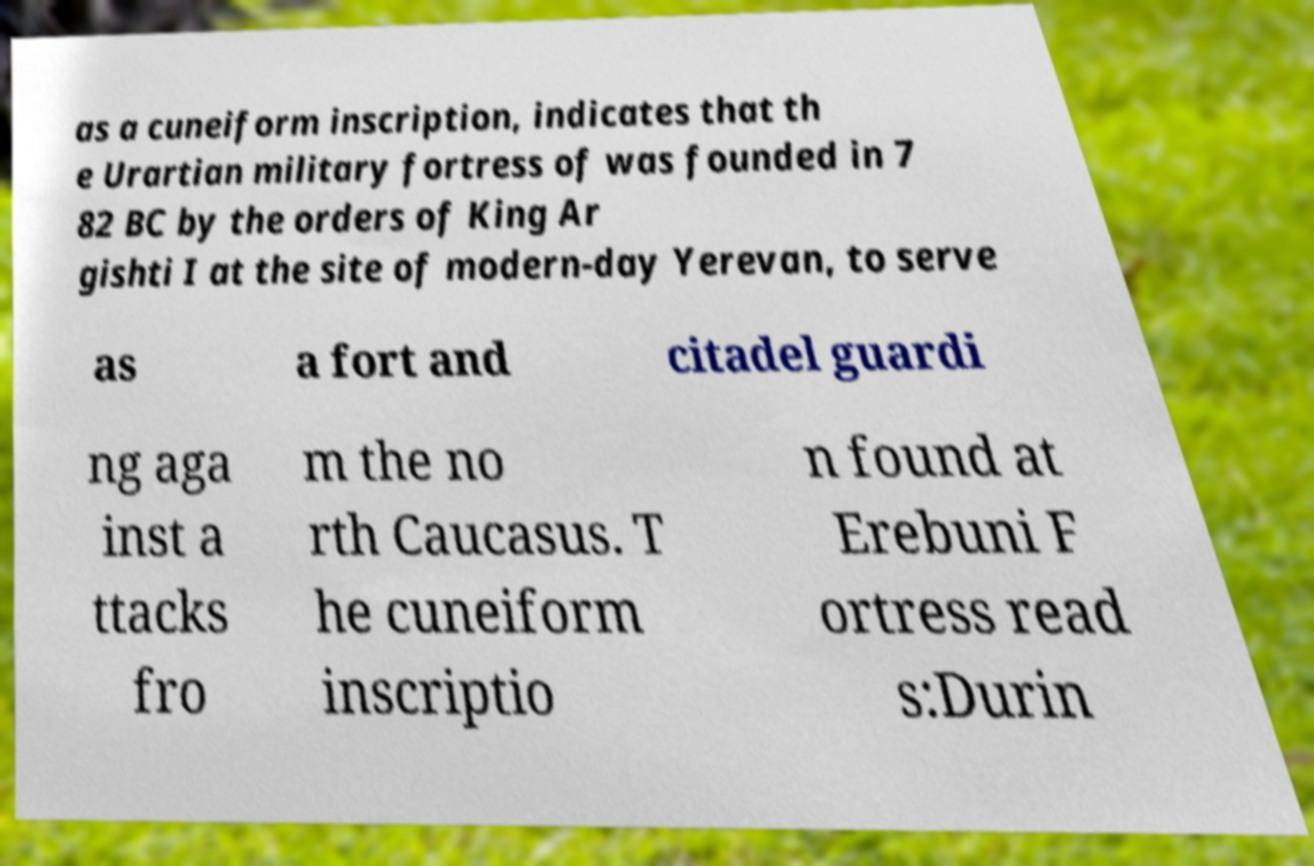Could you extract and type out the text from this image? as a cuneiform inscription, indicates that th e Urartian military fortress of was founded in 7 82 BC by the orders of King Ar gishti I at the site of modern-day Yerevan, to serve as a fort and citadel guardi ng aga inst a ttacks fro m the no rth Caucasus. T he cuneiform inscriptio n found at Erebuni F ortress read s:Durin 